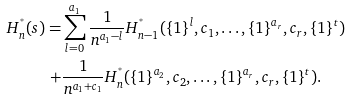<formula> <loc_0><loc_0><loc_500><loc_500>H ^ { ^ { * } } _ { n } ( s ) = & \sum _ { l = 0 } ^ { a _ { 1 } } \frac { 1 } { n ^ { a _ { 1 } - l } } H ^ { ^ { * } } _ { n - 1 } ( \{ 1 \} ^ { l } , c _ { 1 } , \dots , \{ 1 \} ^ { a _ { r } } , c _ { r } , \{ 1 \} ^ { t } ) \\ + & \frac { 1 } { n ^ { a _ { 1 } + c _ { 1 } } } H ^ { ^ { * } } _ { n } ( \{ 1 \} ^ { a _ { 2 } } , c _ { 2 } , \dots , \{ 1 \} ^ { a _ { r } } , c _ { r } , \{ 1 \} ^ { t } ) .</formula> 